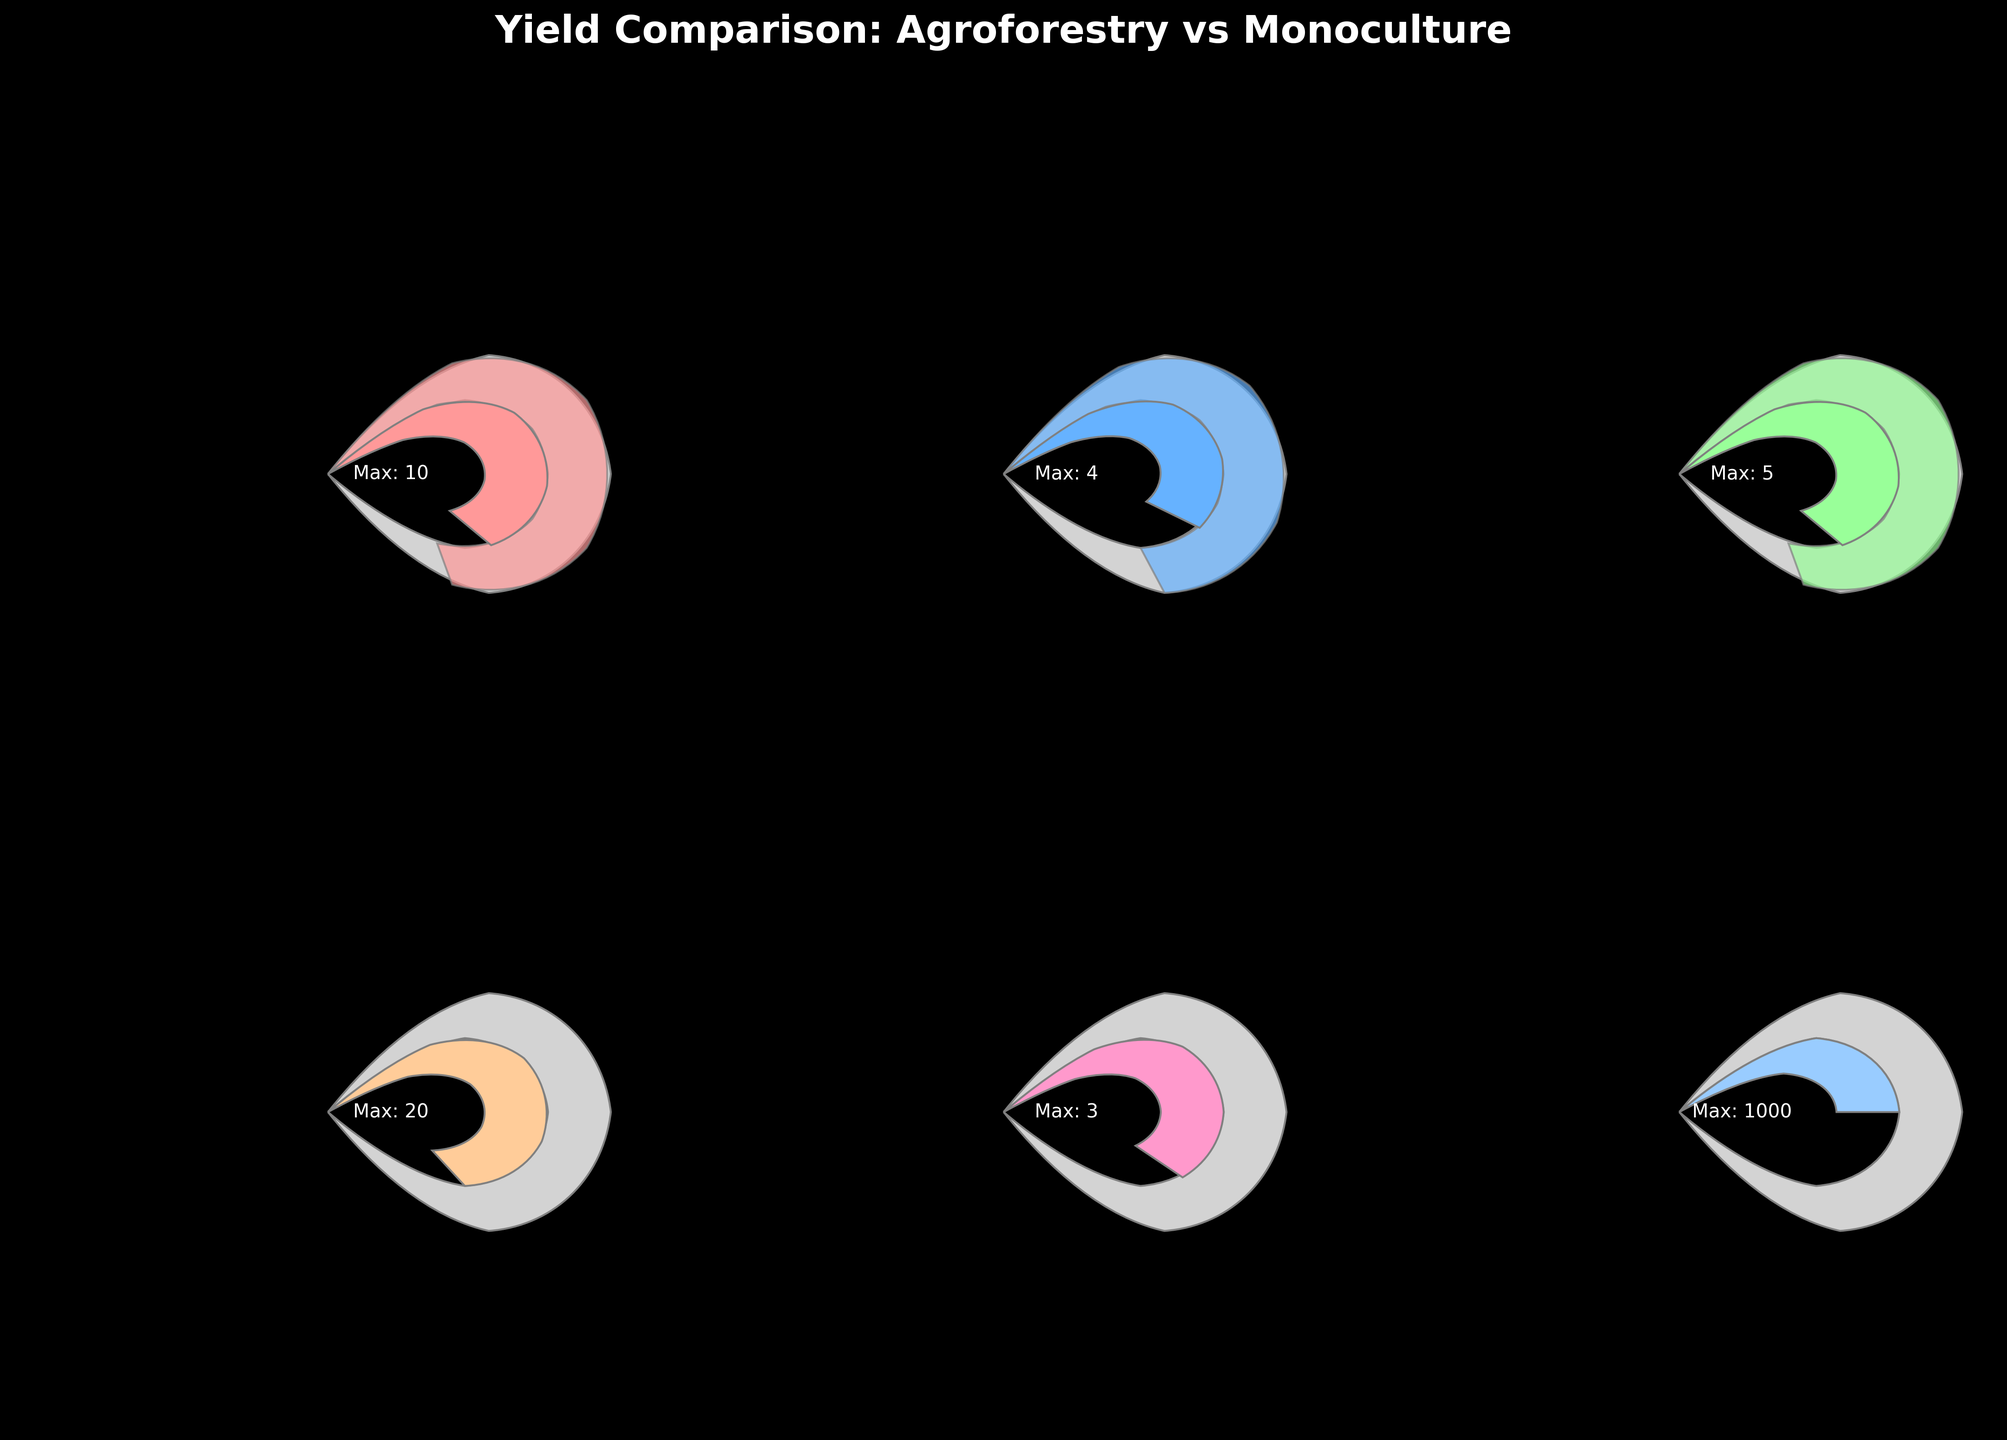What is the title of the figure? The title of the figure is displayed at the top and reads "Yield Comparison: Agroforestry vs Monoculture". This summarises what the figure is about.
Answer: Yield Comparison: Agroforestry vs Monoculture Which crop has the highest agroforestry yield? By looking at the gauges with the highest value in the agroforestry section, Apples have an agroforestry yield of 15 tons/ha, which is the highest.
Answer: Apples How does the monoculture yield of Corn compare to its agroforestry yield? The gauge for Corn shows that the monoculture yield is 8 tons/ha, while the agroforestry yield is 7 tons/ha. The monoculture yield is 1 ton/ha higher than the agroforestry yield.
Answer: Monoculture is 1 ton/ha higher What is the maximum yield for Timber in board feet/ha? According to the gauge for Timber, the maximum yield indicated is 1000 board feet/ha.
Answer: 1000 board feet/ha Which crop shows no yield under monoculture conditions but has yield under agroforestry conditions? Timber, Apples, and Hazelnuts have no yield under monoculture but have yield under agroforestry as indicated by the zero values in monoculture and non-zero values in agroforestry.
Answer: Timber, Apples, and Hazelnuts How many crops are assessed in the figure? Each subplot represents one crop, and there are six such subplots. Therefore, the figure assesses six crops.
Answer: 6 crops What is the agroforestry yield for Soybeans, and how does it compare to its maximum yield? The agroforestry yield for Soybeans is 2.5 tons/ha, whereas the maximum yield for Soybeans is 4 tons/ha. 2.5 is 62.5% of 4.
Answer: 62.5% of the maximum yield What is the difference in yield between monoculture and agroforestry for Wheat? The gauge for Wheat shows monoculture yield at 4 tons/ha and agroforestry yield at 3.5 tons/ha. The difference is 4 - 3.5 = 0.5 tons/ha.
Answer: 0.5 tons/ha Which crop has the lowest maximum yield among those that have yield under both monoculture and agroforestry conditions? Among Corn, Soybeans, and Wheat, Soybeans have the lowest maximum yield of 4 tons/ha.
Answer: Soybeans What color represents the gauge for Apples? The wedge for Apples is displayed in a color shade of light purple.
Answer: Light purple 